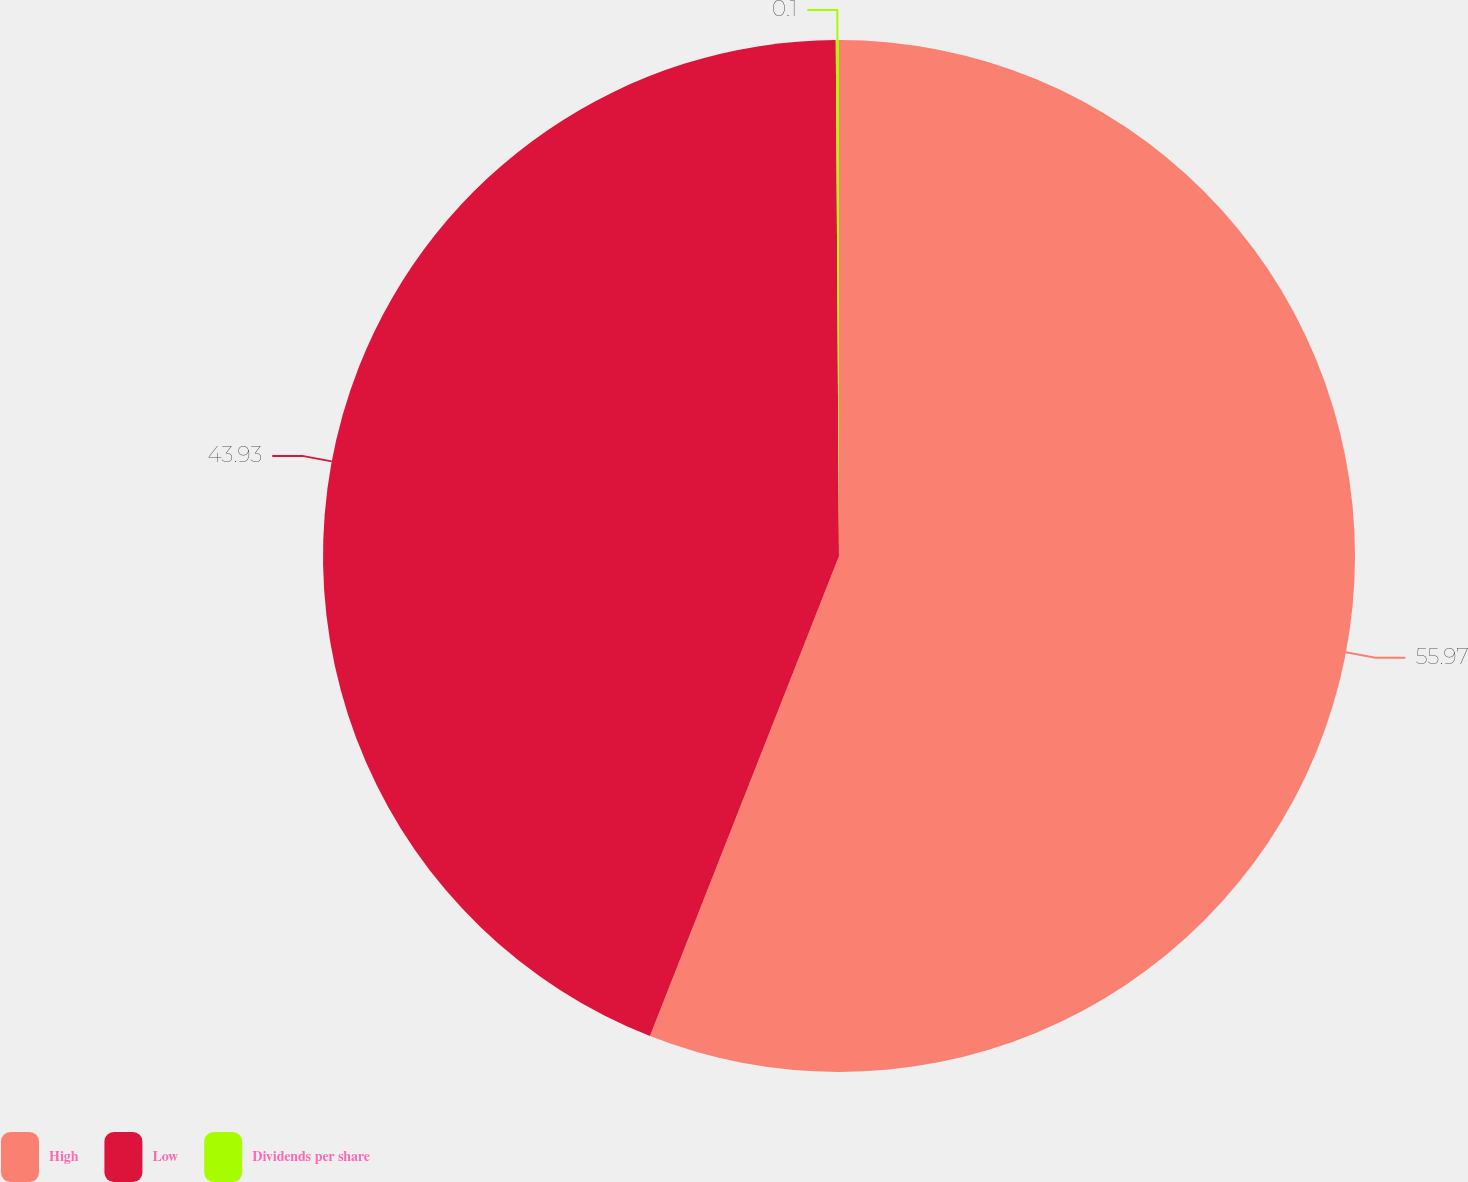Convert chart. <chart><loc_0><loc_0><loc_500><loc_500><pie_chart><fcel>High<fcel>Low<fcel>Dividends per share<nl><fcel>55.97%<fcel>43.93%<fcel>0.1%<nl></chart> 